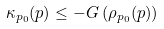<formula> <loc_0><loc_0><loc_500><loc_500>\kappa _ { p _ { 0 } } ( p ) \leq - G \left ( \rho _ { p _ { 0 } } ( p ) \right )</formula> 